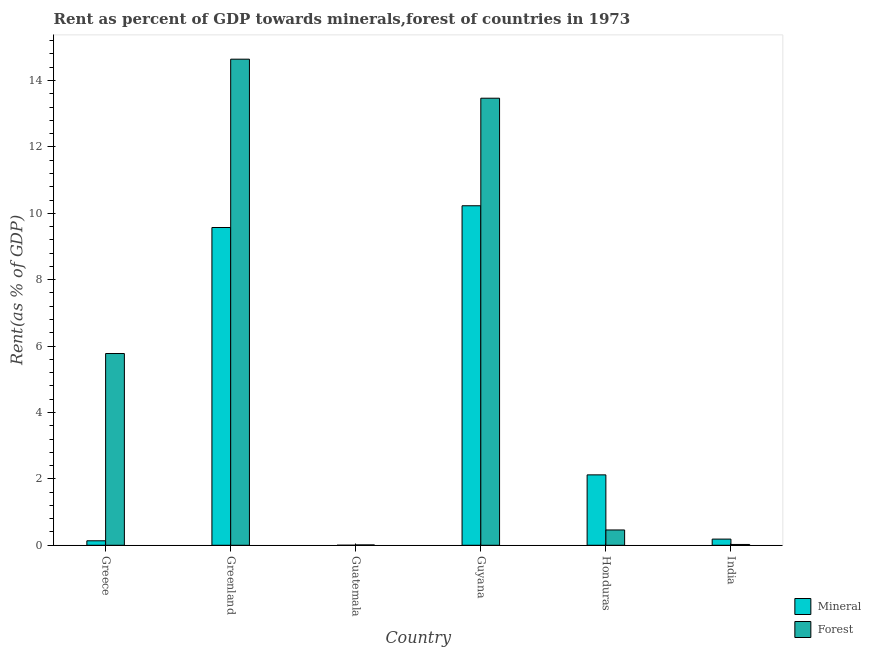How many different coloured bars are there?
Offer a very short reply. 2. Are the number of bars per tick equal to the number of legend labels?
Offer a terse response. Yes. Are the number of bars on each tick of the X-axis equal?
Make the answer very short. Yes. How many bars are there on the 4th tick from the left?
Offer a very short reply. 2. In how many cases, is the number of bars for a given country not equal to the number of legend labels?
Ensure brevity in your answer.  0. What is the mineral rent in Guatemala?
Your answer should be very brief. 0. Across all countries, what is the maximum mineral rent?
Ensure brevity in your answer.  10.23. Across all countries, what is the minimum forest rent?
Provide a short and direct response. 0.01. In which country was the forest rent maximum?
Keep it short and to the point. Greenland. In which country was the mineral rent minimum?
Offer a terse response. Guatemala. What is the total forest rent in the graph?
Give a very brief answer. 34.38. What is the difference between the forest rent in Greece and that in Guatemala?
Offer a terse response. 5.77. What is the difference between the mineral rent in India and the forest rent in Greenland?
Offer a terse response. -14.46. What is the average mineral rent per country?
Provide a short and direct response. 3.71. What is the difference between the forest rent and mineral rent in Honduras?
Make the answer very short. -1.66. In how many countries, is the forest rent greater than 4.8 %?
Your answer should be compact. 3. What is the ratio of the forest rent in Greenland to that in Guatemala?
Ensure brevity in your answer.  1356.64. Is the mineral rent in Greece less than that in Greenland?
Offer a very short reply. Yes. What is the difference between the highest and the second highest mineral rent?
Your response must be concise. 0.66. What is the difference between the highest and the lowest forest rent?
Provide a succinct answer. 14.63. Is the sum of the mineral rent in Greece and Honduras greater than the maximum forest rent across all countries?
Your response must be concise. No. What does the 1st bar from the left in Guyana represents?
Offer a very short reply. Mineral. What does the 2nd bar from the right in Guatemala represents?
Provide a short and direct response. Mineral. How many bars are there?
Your answer should be compact. 12. Does the graph contain any zero values?
Ensure brevity in your answer.  No. How many legend labels are there?
Your answer should be compact. 2. How are the legend labels stacked?
Your response must be concise. Vertical. What is the title of the graph?
Your answer should be very brief. Rent as percent of GDP towards minerals,forest of countries in 1973. What is the label or title of the X-axis?
Offer a very short reply. Country. What is the label or title of the Y-axis?
Make the answer very short. Rent(as % of GDP). What is the Rent(as % of GDP) of Mineral in Greece?
Keep it short and to the point. 0.13. What is the Rent(as % of GDP) in Forest in Greece?
Your response must be concise. 5.78. What is the Rent(as % of GDP) in Mineral in Greenland?
Provide a succinct answer. 9.57. What is the Rent(as % of GDP) in Forest in Greenland?
Offer a very short reply. 14.64. What is the Rent(as % of GDP) of Mineral in Guatemala?
Ensure brevity in your answer.  0. What is the Rent(as % of GDP) of Forest in Guatemala?
Your answer should be very brief. 0.01. What is the Rent(as % of GDP) in Mineral in Guyana?
Your answer should be very brief. 10.23. What is the Rent(as % of GDP) in Forest in Guyana?
Ensure brevity in your answer.  13.47. What is the Rent(as % of GDP) of Mineral in Honduras?
Keep it short and to the point. 2.12. What is the Rent(as % of GDP) in Forest in Honduras?
Provide a succinct answer. 0.46. What is the Rent(as % of GDP) of Mineral in India?
Your response must be concise. 0.19. What is the Rent(as % of GDP) in Forest in India?
Keep it short and to the point. 0.02. Across all countries, what is the maximum Rent(as % of GDP) of Mineral?
Keep it short and to the point. 10.23. Across all countries, what is the maximum Rent(as % of GDP) of Forest?
Make the answer very short. 14.64. Across all countries, what is the minimum Rent(as % of GDP) in Mineral?
Your answer should be compact. 0. Across all countries, what is the minimum Rent(as % of GDP) in Forest?
Ensure brevity in your answer.  0.01. What is the total Rent(as % of GDP) of Mineral in the graph?
Your answer should be compact. 22.24. What is the total Rent(as % of GDP) in Forest in the graph?
Provide a short and direct response. 34.38. What is the difference between the Rent(as % of GDP) of Mineral in Greece and that in Greenland?
Offer a very short reply. -9.44. What is the difference between the Rent(as % of GDP) of Forest in Greece and that in Greenland?
Your answer should be very brief. -8.87. What is the difference between the Rent(as % of GDP) in Mineral in Greece and that in Guatemala?
Offer a terse response. 0.13. What is the difference between the Rent(as % of GDP) of Forest in Greece and that in Guatemala?
Your response must be concise. 5.77. What is the difference between the Rent(as % of GDP) in Mineral in Greece and that in Guyana?
Your answer should be compact. -10.09. What is the difference between the Rent(as % of GDP) in Forest in Greece and that in Guyana?
Give a very brief answer. -7.69. What is the difference between the Rent(as % of GDP) in Mineral in Greece and that in Honduras?
Offer a terse response. -1.99. What is the difference between the Rent(as % of GDP) of Forest in Greece and that in Honduras?
Make the answer very short. 5.32. What is the difference between the Rent(as % of GDP) in Mineral in Greece and that in India?
Ensure brevity in your answer.  -0.05. What is the difference between the Rent(as % of GDP) of Forest in Greece and that in India?
Provide a short and direct response. 5.75. What is the difference between the Rent(as % of GDP) in Mineral in Greenland and that in Guatemala?
Provide a succinct answer. 9.57. What is the difference between the Rent(as % of GDP) in Forest in Greenland and that in Guatemala?
Your answer should be very brief. 14.63. What is the difference between the Rent(as % of GDP) in Mineral in Greenland and that in Guyana?
Give a very brief answer. -0.66. What is the difference between the Rent(as % of GDP) in Forest in Greenland and that in Guyana?
Your response must be concise. 1.18. What is the difference between the Rent(as % of GDP) in Mineral in Greenland and that in Honduras?
Ensure brevity in your answer.  7.45. What is the difference between the Rent(as % of GDP) in Forest in Greenland and that in Honduras?
Your answer should be compact. 14.18. What is the difference between the Rent(as % of GDP) of Mineral in Greenland and that in India?
Your response must be concise. 9.39. What is the difference between the Rent(as % of GDP) of Forest in Greenland and that in India?
Make the answer very short. 14.62. What is the difference between the Rent(as % of GDP) of Mineral in Guatemala and that in Guyana?
Ensure brevity in your answer.  -10.23. What is the difference between the Rent(as % of GDP) of Forest in Guatemala and that in Guyana?
Offer a terse response. -13.46. What is the difference between the Rent(as % of GDP) in Mineral in Guatemala and that in Honduras?
Provide a short and direct response. -2.12. What is the difference between the Rent(as % of GDP) in Forest in Guatemala and that in Honduras?
Your answer should be compact. -0.45. What is the difference between the Rent(as % of GDP) of Mineral in Guatemala and that in India?
Provide a short and direct response. -0.18. What is the difference between the Rent(as % of GDP) of Forest in Guatemala and that in India?
Offer a very short reply. -0.01. What is the difference between the Rent(as % of GDP) of Mineral in Guyana and that in Honduras?
Ensure brevity in your answer.  8.11. What is the difference between the Rent(as % of GDP) of Forest in Guyana and that in Honduras?
Your answer should be very brief. 13.01. What is the difference between the Rent(as % of GDP) of Mineral in Guyana and that in India?
Keep it short and to the point. 10.04. What is the difference between the Rent(as % of GDP) in Forest in Guyana and that in India?
Provide a succinct answer. 13.44. What is the difference between the Rent(as % of GDP) of Mineral in Honduras and that in India?
Keep it short and to the point. 1.94. What is the difference between the Rent(as % of GDP) in Forest in Honduras and that in India?
Provide a short and direct response. 0.44. What is the difference between the Rent(as % of GDP) in Mineral in Greece and the Rent(as % of GDP) in Forest in Greenland?
Give a very brief answer. -14.51. What is the difference between the Rent(as % of GDP) in Mineral in Greece and the Rent(as % of GDP) in Forest in Guatemala?
Offer a terse response. 0.12. What is the difference between the Rent(as % of GDP) in Mineral in Greece and the Rent(as % of GDP) in Forest in Guyana?
Your answer should be very brief. -13.33. What is the difference between the Rent(as % of GDP) in Mineral in Greece and the Rent(as % of GDP) in Forest in Honduras?
Provide a short and direct response. -0.33. What is the difference between the Rent(as % of GDP) in Mineral in Greece and the Rent(as % of GDP) in Forest in India?
Offer a terse response. 0.11. What is the difference between the Rent(as % of GDP) in Mineral in Greenland and the Rent(as % of GDP) in Forest in Guatemala?
Make the answer very short. 9.56. What is the difference between the Rent(as % of GDP) in Mineral in Greenland and the Rent(as % of GDP) in Forest in Guyana?
Provide a succinct answer. -3.9. What is the difference between the Rent(as % of GDP) in Mineral in Greenland and the Rent(as % of GDP) in Forest in Honduras?
Your answer should be very brief. 9.11. What is the difference between the Rent(as % of GDP) of Mineral in Greenland and the Rent(as % of GDP) of Forest in India?
Your answer should be compact. 9.55. What is the difference between the Rent(as % of GDP) in Mineral in Guatemala and the Rent(as % of GDP) in Forest in Guyana?
Ensure brevity in your answer.  -13.47. What is the difference between the Rent(as % of GDP) of Mineral in Guatemala and the Rent(as % of GDP) of Forest in Honduras?
Offer a terse response. -0.46. What is the difference between the Rent(as % of GDP) of Mineral in Guatemala and the Rent(as % of GDP) of Forest in India?
Your response must be concise. -0.02. What is the difference between the Rent(as % of GDP) of Mineral in Guyana and the Rent(as % of GDP) of Forest in Honduras?
Keep it short and to the point. 9.77. What is the difference between the Rent(as % of GDP) in Mineral in Guyana and the Rent(as % of GDP) in Forest in India?
Make the answer very short. 10.2. What is the difference between the Rent(as % of GDP) in Mineral in Honduras and the Rent(as % of GDP) in Forest in India?
Offer a very short reply. 2.1. What is the average Rent(as % of GDP) of Mineral per country?
Keep it short and to the point. 3.71. What is the average Rent(as % of GDP) of Forest per country?
Offer a terse response. 5.73. What is the difference between the Rent(as % of GDP) of Mineral and Rent(as % of GDP) of Forest in Greece?
Offer a very short reply. -5.64. What is the difference between the Rent(as % of GDP) in Mineral and Rent(as % of GDP) in Forest in Greenland?
Provide a succinct answer. -5.07. What is the difference between the Rent(as % of GDP) of Mineral and Rent(as % of GDP) of Forest in Guatemala?
Make the answer very short. -0.01. What is the difference between the Rent(as % of GDP) of Mineral and Rent(as % of GDP) of Forest in Guyana?
Provide a short and direct response. -3.24. What is the difference between the Rent(as % of GDP) of Mineral and Rent(as % of GDP) of Forest in Honduras?
Provide a short and direct response. 1.66. What is the difference between the Rent(as % of GDP) in Mineral and Rent(as % of GDP) in Forest in India?
Your answer should be very brief. 0.16. What is the ratio of the Rent(as % of GDP) in Mineral in Greece to that in Greenland?
Provide a short and direct response. 0.01. What is the ratio of the Rent(as % of GDP) in Forest in Greece to that in Greenland?
Give a very brief answer. 0.39. What is the ratio of the Rent(as % of GDP) of Mineral in Greece to that in Guatemala?
Provide a short and direct response. 124.85. What is the ratio of the Rent(as % of GDP) in Forest in Greece to that in Guatemala?
Give a very brief answer. 535.14. What is the ratio of the Rent(as % of GDP) in Mineral in Greece to that in Guyana?
Your answer should be very brief. 0.01. What is the ratio of the Rent(as % of GDP) of Forest in Greece to that in Guyana?
Your answer should be very brief. 0.43. What is the ratio of the Rent(as % of GDP) of Mineral in Greece to that in Honduras?
Your answer should be very brief. 0.06. What is the ratio of the Rent(as % of GDP) of Forest in Greece to that in Honduras?
Make the answer very short. 12.52. What is the ratio of the Rent(as % of GDP) in Mineral in Greece to that in India?
Provide a short and direct response. 0.73. What is the ratio of the Rent(as % of GDP) of Forest in Greece to that in India?
Give a very brief answer. 233.69. What is the ratio of the Rent(as % of GDP) of Mineral in Greenland to that in Guatemala?
Offer a very short reply. 8856.95. What is the ratio of the Rent(as % of GDP) in Forest in Greenland to that in Guatemala?
Offer a terse response. 1356.64. What is the ratio of the Rent(as % of GDP) of Mineral in Greenland to that in Guyana?
Provide a short and direct response. 0.94. What is the ratio of the Rent(as % of GDP) in Forest in Greenland to that in Guyana?
Offer a terse response. 1.09. What is the ratio of the Rent(as % of GDP) of Mineral in Greenland to that in Honduras?
Ensure brevity in your answer.  4.51. What is the ratio of the Rent(as % of GDP) in Forest in Greenland to that in Honduras?
Give a very brief answer. 31.75. What is the ratio of the Rent(as % of GDP) in Mineral in Greenland to that in India?
Your answer should be compact. 51.48. What is the ratio of the Rent(as % of GDP) in Forest in Greenland to that in India?
Ensure brevity in your answer.  592.42. What is the ratio of the Rent(as % of GDP) in Forest in Guatemala to that in Guyana?
Ensure brevity in your answer.  0. What is the ratio of the Rent(as % of GDP) in Mineral in Guatemala to that in Honduras?
Provide a succinct answer. 0. What is the ratio of the Rent(as % of GDP) in Forest in Guatemala to that in Honduras?
Offer a very short reply. 0.02. What is the ratio of the Rent(as % of GDP) in Mineral in Guatemala to that in India?
Ensure brevity in your answer.  0.01. What is the ratio of the Rent(as % of GDP) in Forest in Guatemala to that in India?
Provide a short and direct response. 0.44. What is the ratio of the Rent(as % of GDP) in Mineral in Guyana to that in Honduras?
Your answer should be compact. 4.82. What is the ratio of the Rent(as % of GDP) of Forest in Guyana to that in Honduras?
Provide a short and direct response. 29.2. What is the ratio of the Rent(as % of GDP) in Mineral in Guyana to that in India?
Make the answer very short. 55. What is the ratio of the Rent(as % of GDP) in Forest in Guyana to that in India?
Provide a succinct answer. 544.86. What is the ratio of the Rent(as % of GDP) of Mineral in Honduras to that in India?
Your answer should be very brief. 11.41. What is the ratio of the Rent(as % of GDP) in Forest in Honduras to that in India?
Provide a succinct answer. 18.66. What is the difference between the highest and the second highest Rent(as % of GDP) in Mineral?
Ensure brevity in your answer.  0.66. What is the difference between the highest and the second highest Rent(as % of GDP) of Forest?
Offer a terse response. 1.18. What is the difference between the highest and the lowest Rent(as % of GDP) in Mineral?
Offer a very short reply. 10.23. What is the difference between the highest and the lowest Rent(as % of GDP) in Forest?
Your answer should be compact. 14.63. 